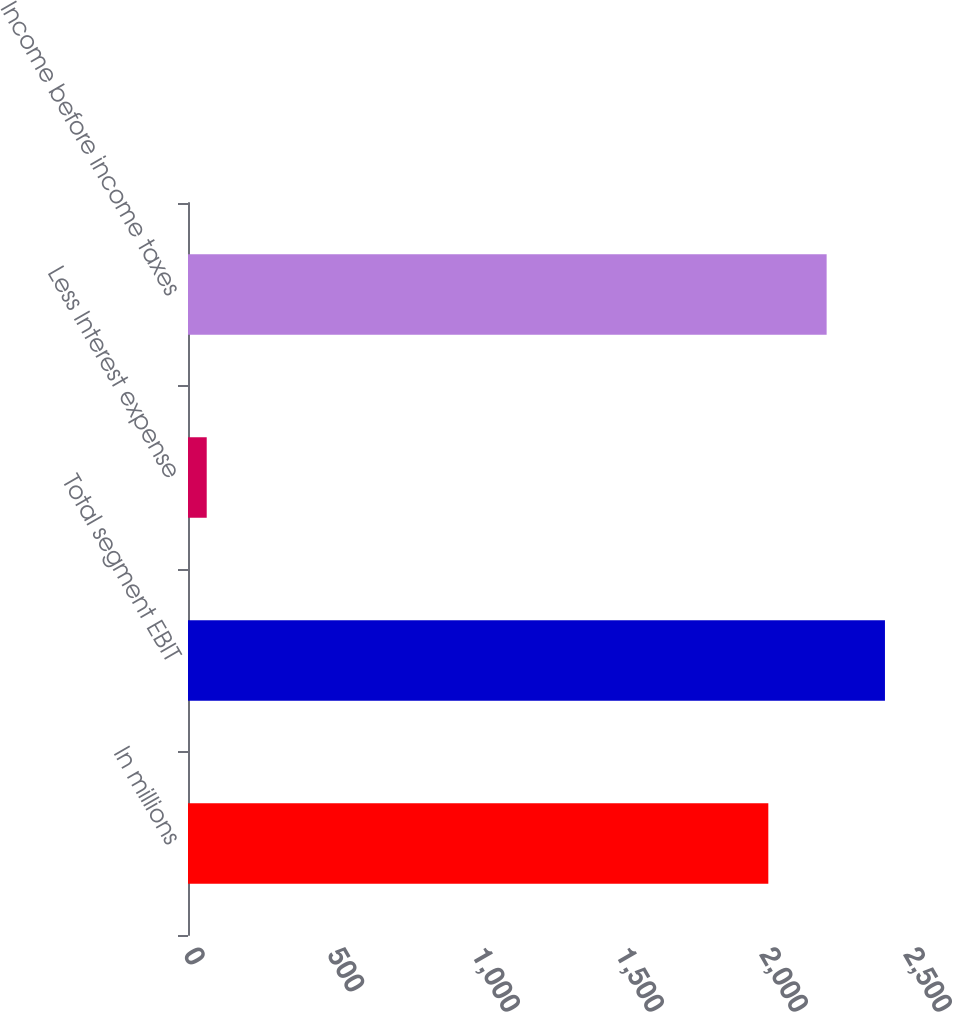Convert chart. <chart><loc_0><loc_0><loc_500><loc_500><bar_chart><fcel>In millions<fcel>Total segment EBIT<fcel>Less Interest expense<fcel>Income before income taxes<nl><fcel>2015<fcel>2420<fcel>65<fcel>2217.5<nl></chart> 